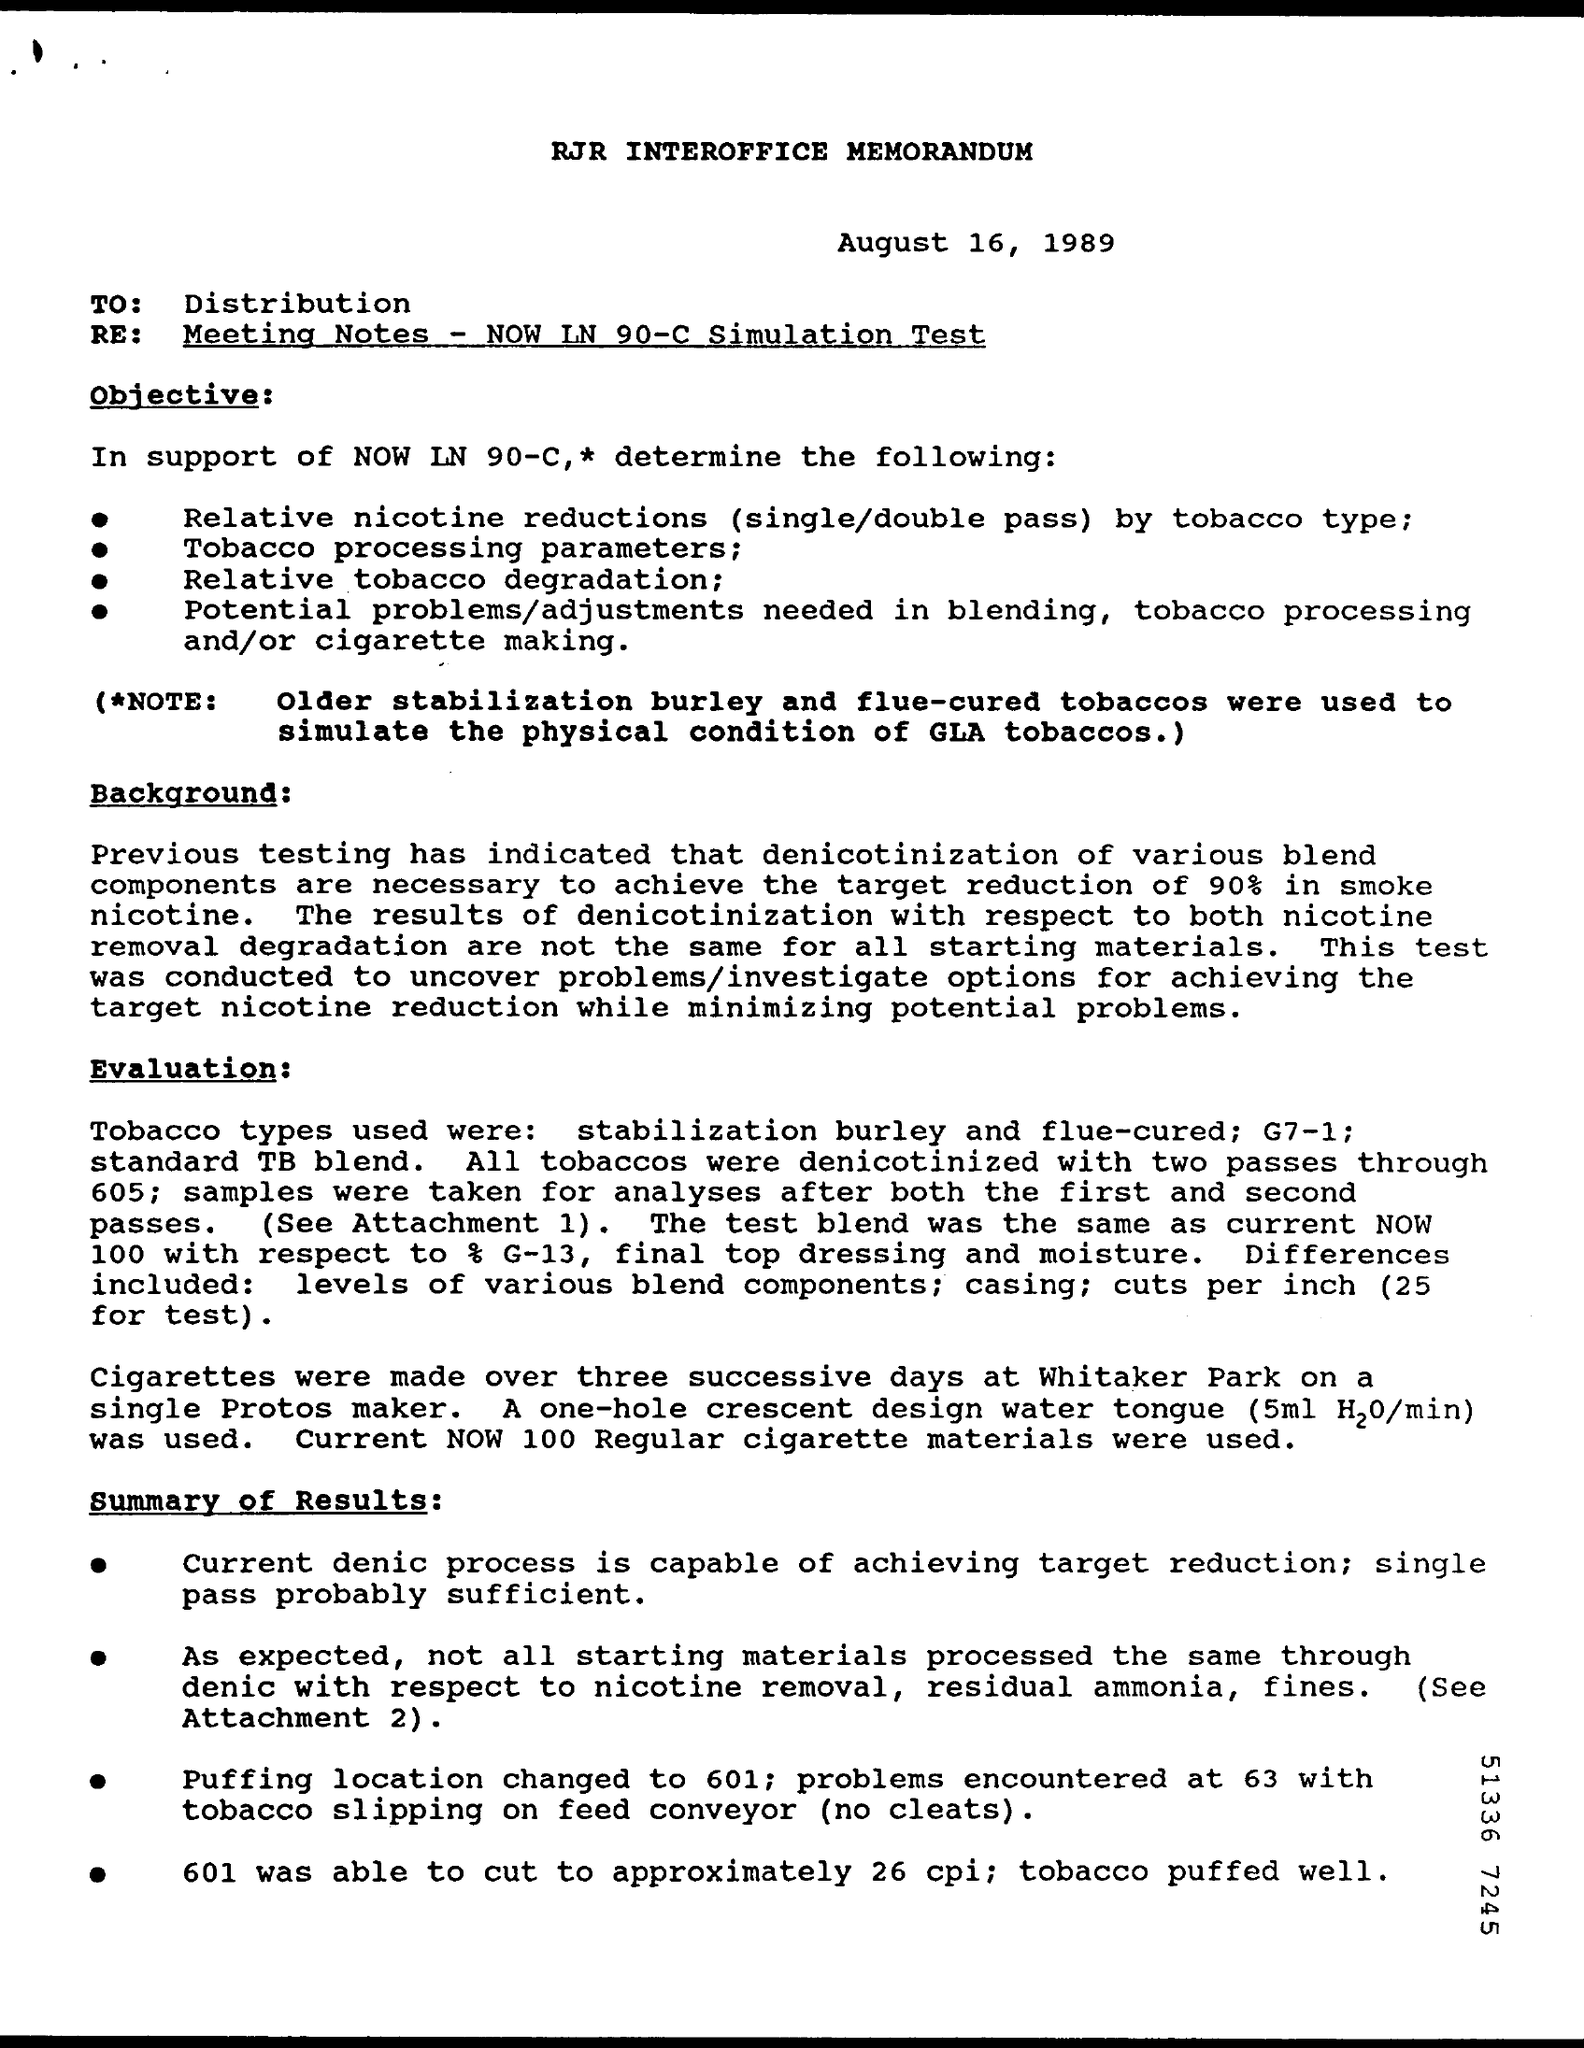What is the date on the memorandum?
Give a very brief answer. August 16, 1989. To Whom is this memorandum addressed to?
Offer a terse response. Distribution. 